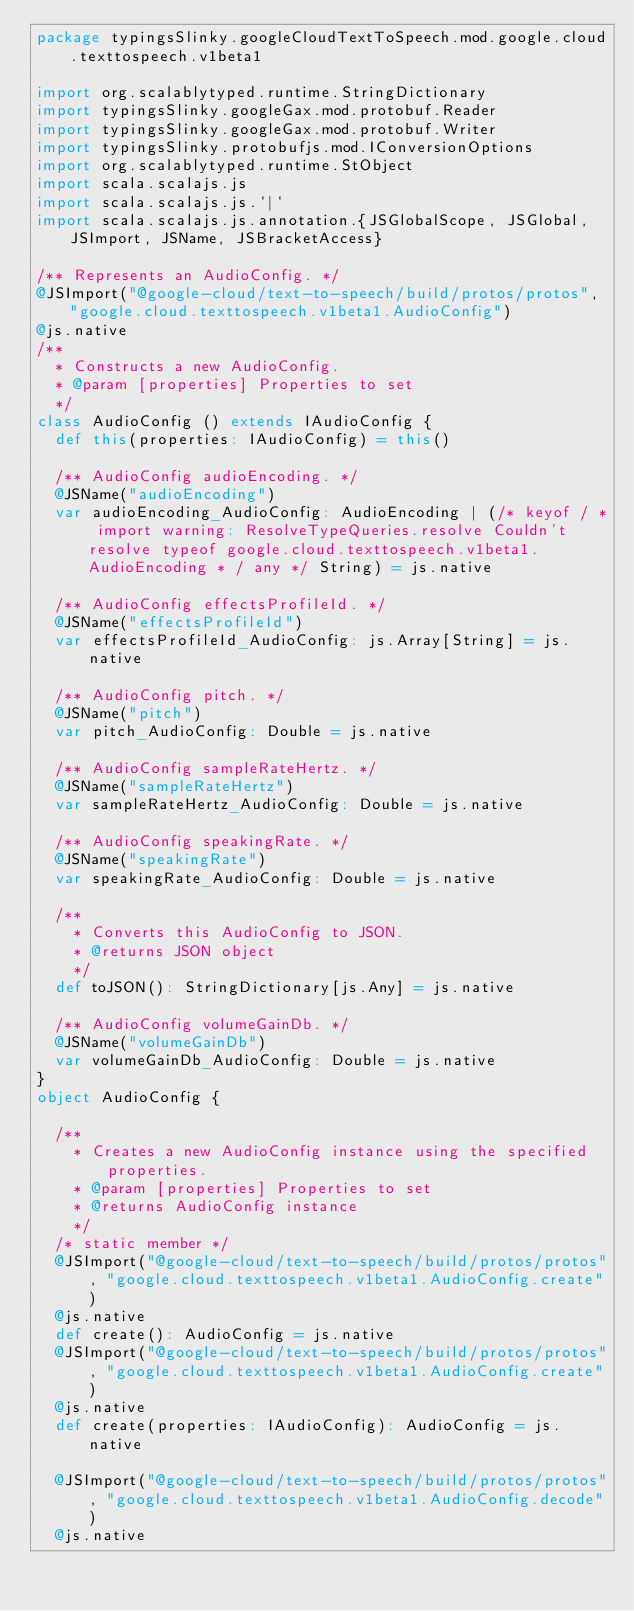<code> <loc_0><loc_0><loc_500><loc_500><_Scala_>package typingsSlinky.googleCloudTextToSpeech.mod.google.cloud.texttospeech.v1beta1

import org.scalablytyped.runtime.StringDictionary
import typingsSlinky.googleGax.mod.protobuf.Reader
import typingsSlinky.googleGax.mod.protobuf.Writer
import typingsSlinky.protobufjs.mod.IConversionOptions
import org.scalablytyped.runtime.StObject
import scala.scalajs.js
import scala.scalajs.js.`|`
import scala.scalajs.js.annotation.{JSGlobalScope, JSGlobal, JSImport, JSName, JSBracketAccess}

/** Represents an AudioConfig. */
@JSImport("@google-cloud/text-to-speech/build/protos/protos", "google.cloud.texttospeech.v1beta1.AudioConfig")
@js.native
/**
  * Constructs a new AudioConfig.
  * @param [properties] Properties to set
  */
class AudioConfig () extends IAudioConfig {
  def this(properties: IAudioConfig) = this()
  
  /** AudioConfig audioEncoding. */
  @JSName("audioEncoding")
  var audioEncoding_AudioConfig: AudioEncoding | (/* keyof / * import warning: ResolveTypeQueries.resolve Couldn't resolve typeof google.cloud.texttospeech.v1beta1.AudioEncoding * / any */ String) = js.native
  
  /** AudioConfig effectsProfileId. */
  @JSName("effectsProfileId")
  var effectsProfileId_AudioConfig: js.Array[String] = js.native
  
  /** AudioConfig pitch. */
  @JSName("pitch")
  var pitch_AudioConfig: Double = js.native
  
  /** AudioConfig sampleRateHertz. */
  @JSName("sampleRateHertz")
  var sampleRateHertz_AudioConfig: Double = js.native
  
  /** AudioConfig speakingRate. */
  @JSName("speakingRate")
  var speakingRate_AudioConfig: Double = js.native
  
  /**
    * Converts this AudioConfig to JSON.
    * @returns JSON object
    */
  def toJSON(): StringDictionary[js.Any] = js.native
  
  /** AudioConfig volumeGainDb. */
  @JSName("volumeGainDb")
  var volumeGainDb_AudioConfig: Double = js.native
}
object AudioConfig {
  
  /**
    * Creates a new AudioConfig instance using the specified properties.
    * @param [properties] Properties to set
    * @returns AudioConfig instance
    */
  /* static member */
  @JSImport("@google-cloud/text-to-speech/build/protos/protos", "google.cloud.texttospeech.v1beta1.AudioConfig.create")
  @js.native
  def create(): AudioConfig = js.native
  @JSImport("@google-cloud/text-to-speech/build/protos/protos", "google.cloud.texttospeech.v1beta1.AudioConfig.create")
  @js.native
  def create(properties: IAudioConfig): AudioConfig = js.native
  
  @JSImport("@google-cloud/text-to-speech/build/protos/protos", "google.cloud.texttospeech.v1beta1.AudioConfig.decode")
  @js.native</code> 